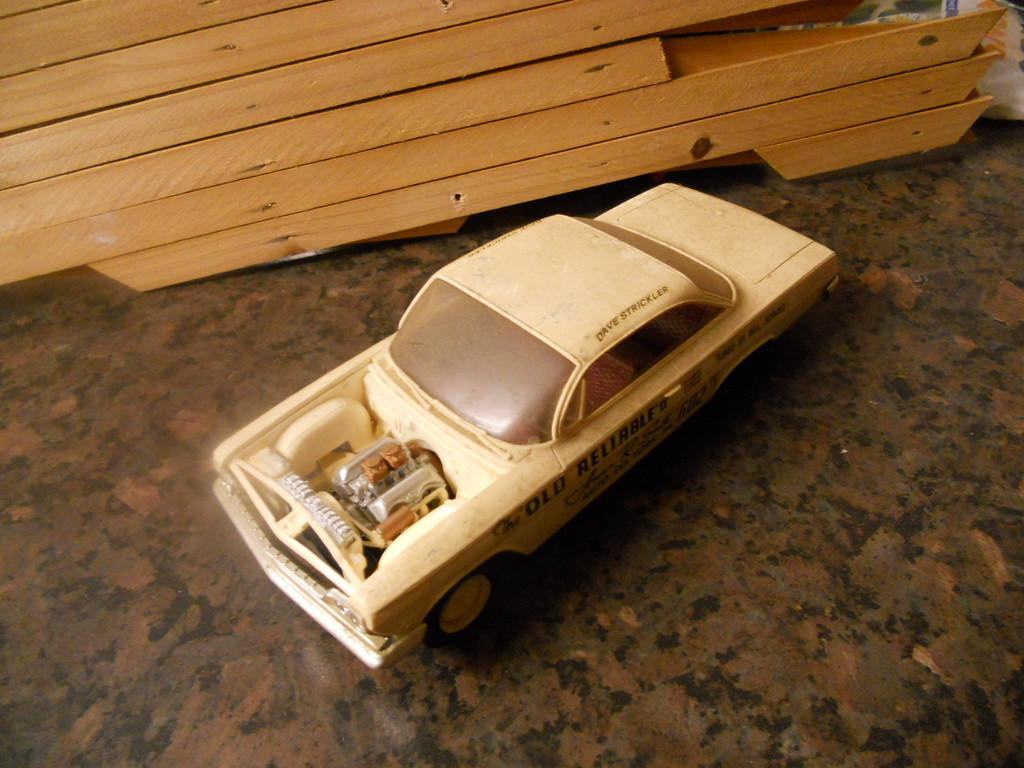What type of vehicle is in the center of the image? There is a Buick Wildcat in the center of the image. What material is used for the boards at the top side of the image? The boards at the top side of the image are made of wood. What date is circled on the calendar in the image? There is no calendar present in the image, so it is not possible to answer that question. 